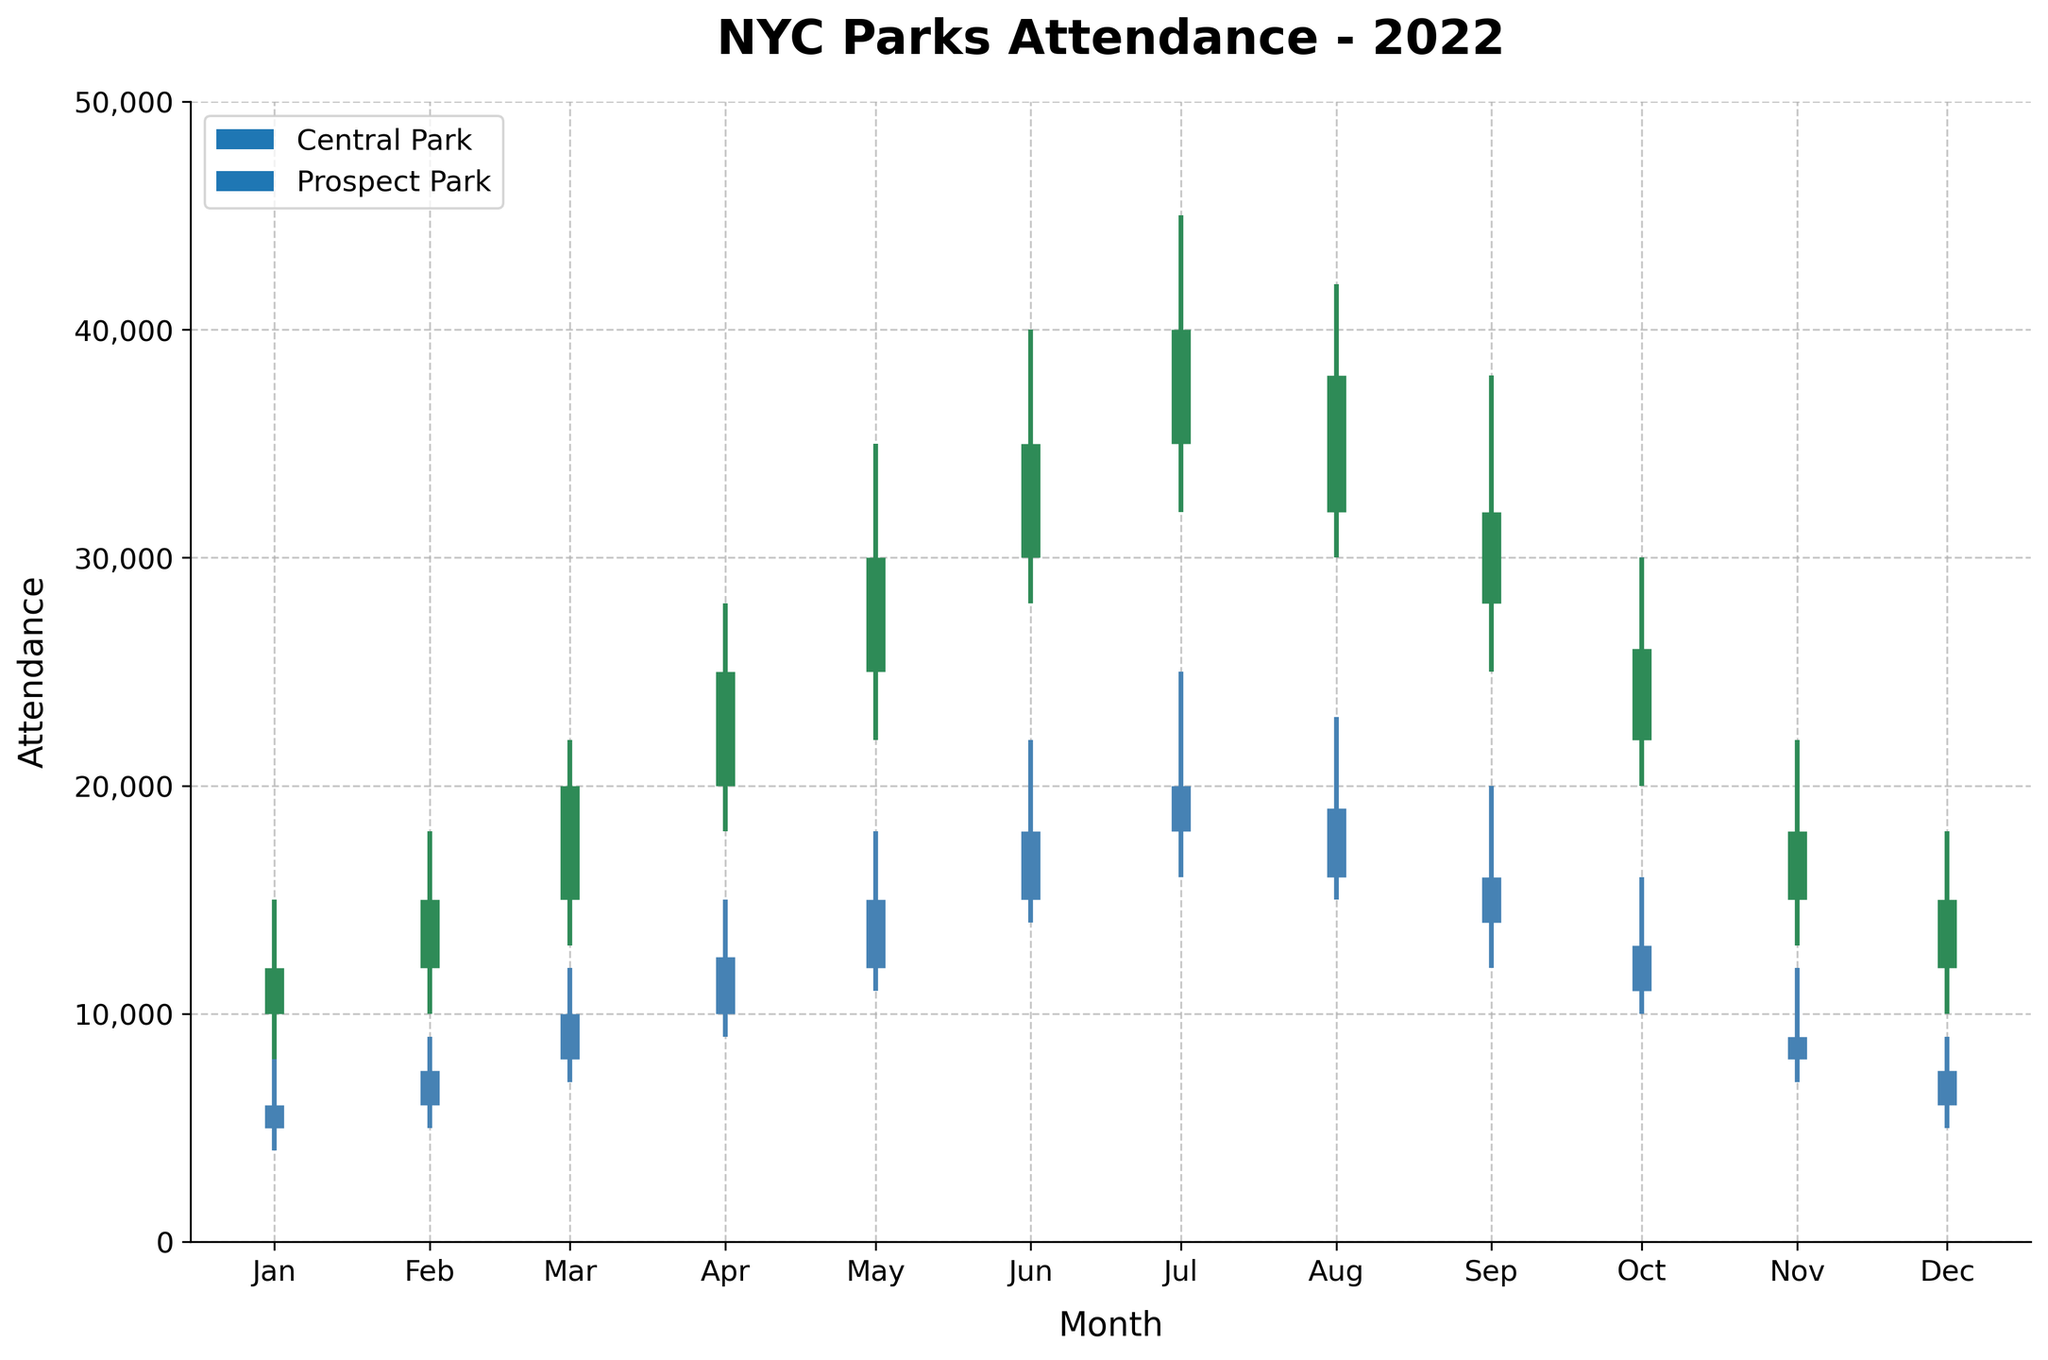What is the title of the figure? The title is usually placed at the top of the figure. Here, it reads "NYC Parks Attendance - 2022" which describes the content of the chart.
Answer: NYC Parks Attendance - 2022 Which park had higher attendance in July? To determine which park had higher attendance in July, look at the height of the close marks in the OHLC visuals for July month. Central Park's close value in July is 40,000, whereas Prospect Park's close value in July is 20,000.
Answer: Central Park What is the difference in attendance between the highest peak and the lowest dip for Central Park? First, find Central Park's highest point which is in July (45,000) and its lowest point which is in January (8,000). The difference is calculated as 45,000 - 8,000 = 37,000.
Answer: 37,000 In which month did Prospect Park experience its highest attendance? Observing the high bars in the OHLC visual for each month, Prospect Park reached its highest attendance of 25,000 in July.
Answer: July What are the open and close values for Central Park in April? Look for the visual representing Central Park in April and identify the open and close lines: the open is at 20,000 and the close is at 25,000.
Answer: Open: 20,000 and Close: 25,000 Compare the attendance trends of Central Park and Prospect Park throughout the year. Which park had more fluctuations? Central Park shows larger swings in values from month to month, with highs reaching up to 45,000 and lows dropping to 8,000. Prospect Park's fluctuations are more moderate, with highs going up to 25,000 and lows around 4,000.
Answer: Central Park During which month did both parks have their lowest attendance, and what were those values? Observing the chart, both parks have their lowest attendance in January. Central Park's low is 8,000 and Prospect Park's low is 4,000.
Answer: January; Central Park: 8,000 and Prospect Park: 4,000 What is the combined attendance for both parks in May? To find the combined attendance, sum up the close values of both parks in May. Central Park's close in May is 30,000 and Prospect Park's close in May is 15,000. Therefore, the combined attendance is 30,000 + 15,000 = 45,000.
Answer: 45,000 What is the attendance difference between the open and close values for Prospect Park in June? Subtract the open value from the close value for Prospect Park in June. Prospect Park's open in June is 15,000 and its close is 18,000, so the difference is 18,000 - 15,000 = 3,000.
Answer: 3,000 